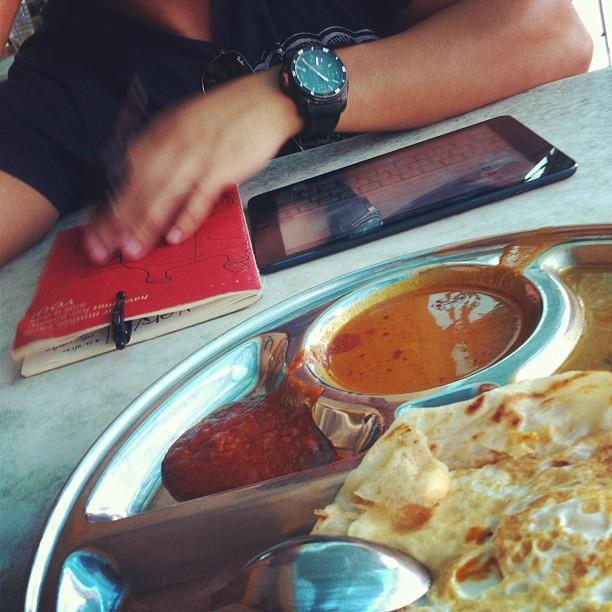What is the silver plate the man is using made of?
Select the accurate answer and provide explanation: 'Answer: answer
Rationale: rationale.'
Options: Metal, plastic, paper, wood. Answer: metal.
Rationale: The silver plate is made of metal. 